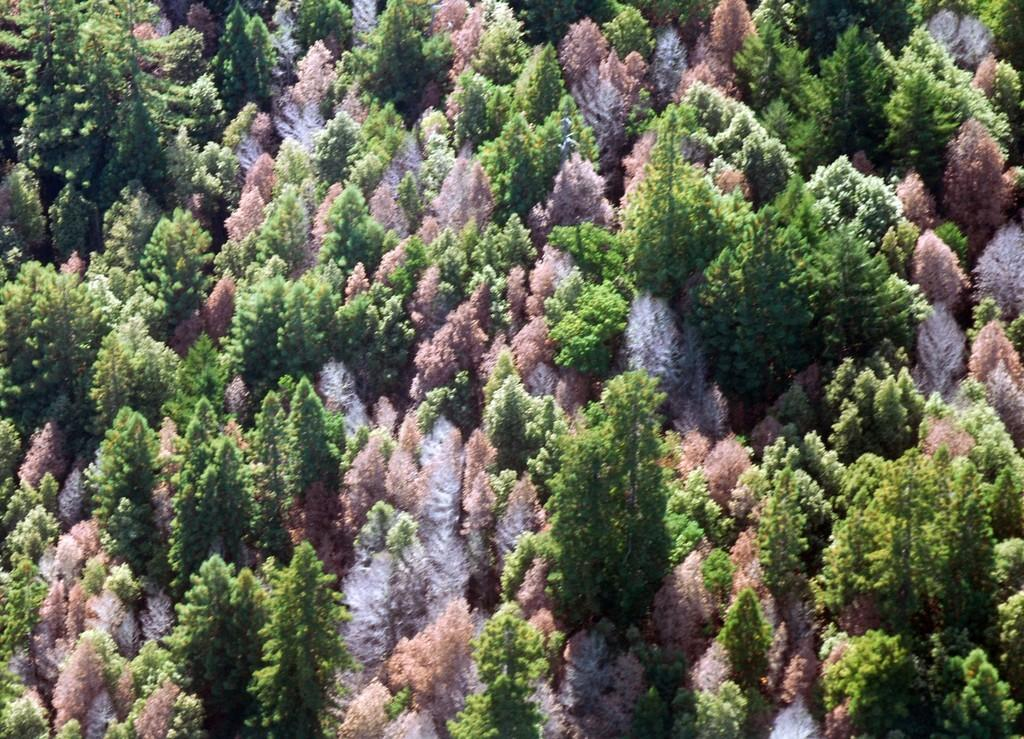What type of vegetation can be seen in the image? There are trees in the image. Can you describe the appearance of the trees? The trees have different colors. What type of heart condition does the lawyer's father have in the image? There is no reference to a lawyer, a father, or a heart condition in the image; it only features trees with different colors. 